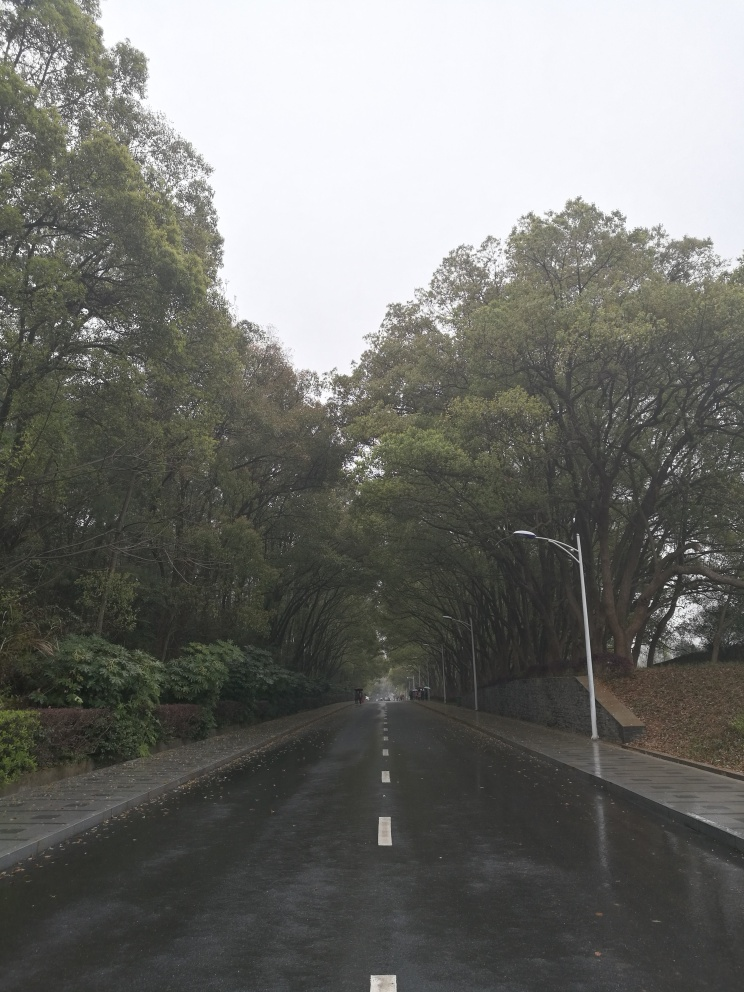What potential story or mood does this image convey? The image conveys a mood of introspection and stillness, perhaps suggesting a story of solitude or reflection. The absence of people and the quiet, empty road might evoke in viewers a contemplative state of mind, as the scene seems to be paused in a moment of calm before the bustle of daily life begins or resumes. Could there be a narrative significance to the wet surfaces and overcast sky? Yes, the wet surfaces and overcast sky might be used to symbolize cleansing, renewal, or a sense of freshness after the rain. They could also suggest a moment of transition or the presence of lingering thoughts and emotions after a significant event, leaving room for interpretation based on the viewer's personal experiences and imagination. 